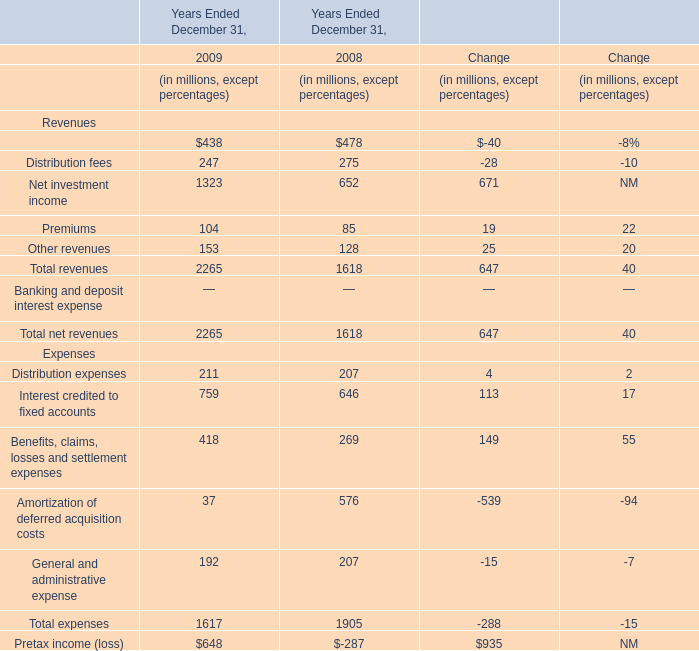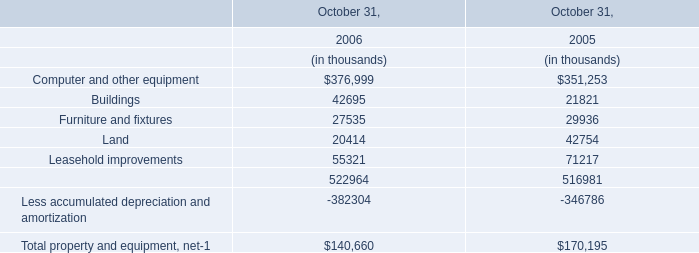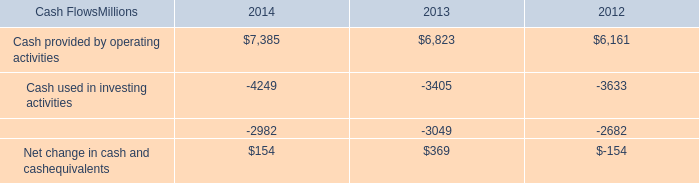what was the percentage change in cash provided by operating activities from 2013 to 2014? 
Computations: ((7385 - 6823) / 6823)
Answer: 0.08237. 